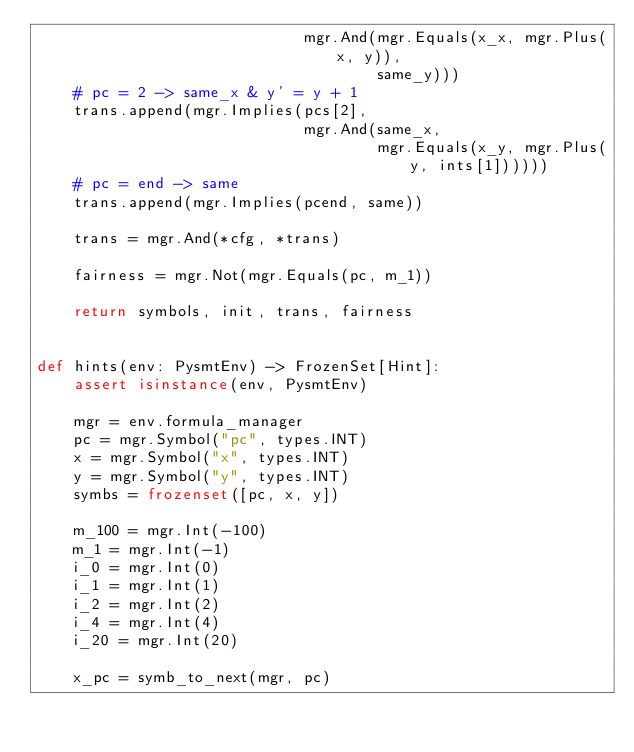<code> <loc_0><loc_0><loc_500><loc_500><_Python_>                             mgr.And(mgr.Equals(x_x, mgr.Plus(x, y)),
                                     same_y)))
    # pc = 2 -> same_x & y' = y + 1
    trans.append(mgr.Implies(pcs[2],
                             mgr.And(same_x,
                                     mgr.Equals(x_y, mgr.Plus(y, ints[1])))))
    # pc = end -> same
    trans.append(mgr.Implies(pcend, same))

    trans = mgr.And(*cfg, *trans)

    fairness = mgr.Not(mgr.Equals(pc, m_1))

    return symbols, init, trans, fairness


def hints(env: PysmtEnv) -> FrozenSet[Hint]:
    assert isinstance(env, PysmtEnv)

    mgr = env.formula_manager
    pc = mgr.Symbol("pc", types.INT)
    x = mgr.Symbol("x", types.INT)
    y = mgr.Symbol("y", types.INT)
    symbs = frozenset([pc, x, y])

    m_100 = mgr.Int(-100)
    m_1 = mgr.Int(-1)
    i_0 = mgr.Int(0)
    i_1 = mgr.Int(1)
    i_2 = mgr.Int(2)
    i_4 = mgr.Int(4)
    i_20 = mgr.Int(20)

    x_pc = symb_to_next(mgr, pc)</code> 